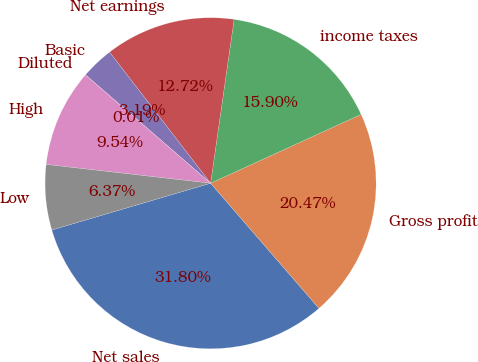Convert chart. <chart><loc_0><loc_0><loc_500><loc_500><pie_chart><fcel>Net sales<fcel>Gross profit<fcel>income taxes<fcel>Net earnings<fcel>Basic<fcel>Diluted<fcel>High<fcel>Low<nl><fcel>31.8%<fcel>20.47%<fcel>15.9%<fcel>12.72%<fcel>3.19%<fcel>0.01%<fcel>9.54%<fcel>6.37%<nl></chart> 